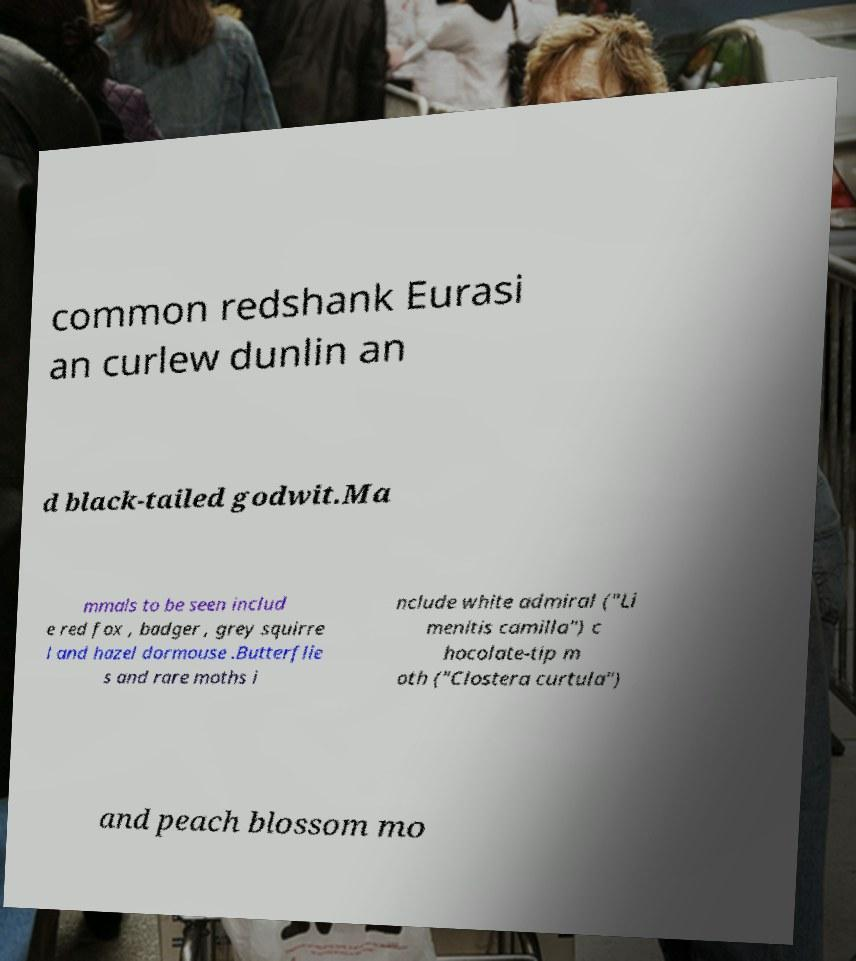Could you assist in decoding the text presented in this image and type it out clearly? common redshank Eurasi an curlew dunlin an d black-tailed godwit.Ma mmals to be seen includ e red fox , badger , grey squirre l and hazel dormouse .Butterflie s and rare moths i nclude white admiral ("Li menitis camilla") c hocolate-tip m oth ("Clostera curtula") and peach blossom mo 